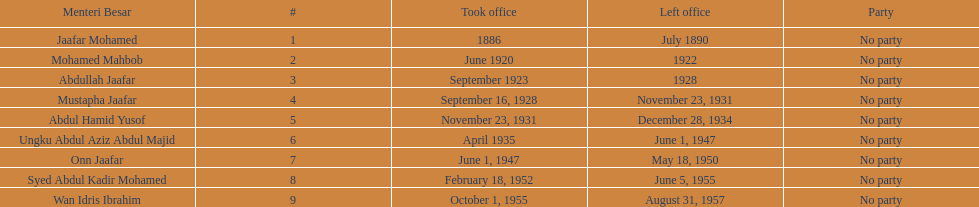What is the number of menteri besar that served 4 or more years? 3. 